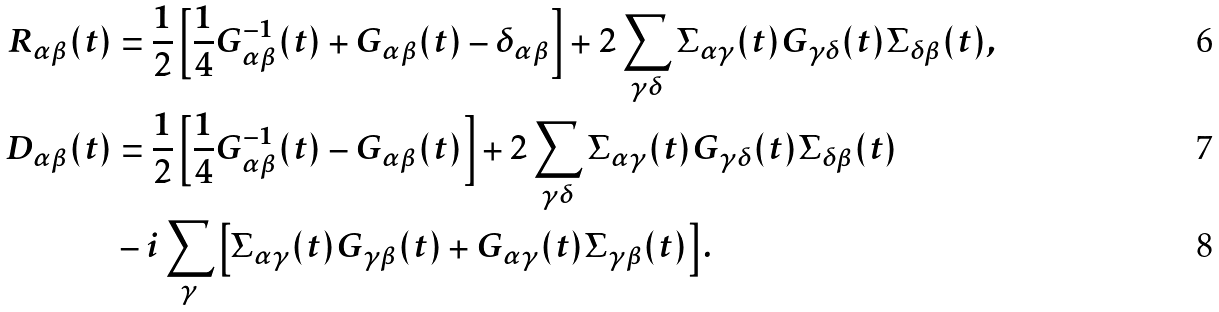Convert formula to latex. <formula><loc_0><loc_0><loc_500><loc_500>R _ { \alpha \beta } ( t ) & = \frac { 1 } { 2 } \left [ \frac { 1 } { 4 } G ^ { - 1 } _ { \alpha \beta } ( t ) + G _ { \alpha \beta } ( t ) - \delta _ { \alpha \beta } \right ] + 2 \sum _ { \gamma \delta } \Sigma _ { \alpha \gamma } ( t ) G _ { \gamma \delta } ( t ) \Sigma _ { \delta \beta } ( t ) , \\ D _ { \alpha \beta } ( t ) & = \frac { 1 } { 2 } \left [ \frac { 1 } { 4 } G ^ { - 1 } _ { \alpha \beta } ( t ) - G _ { \alpha \beta } ( t ) \right ] + 2 \sum _ { \gamma \delta } \Sigma _ { \alpha \gamma } ( t ) G _ { \gamma \delta } ( t ) \Sigma _ { \delta \beta } ( t ) \\ & - i \sum _ { \gamma } \left [ \Sigma _ { \alpha \gamma } ( t ) G _ { \gamma \beta } ( t ) + G _ { \alpha \gamma } ( t ) \Sigma _ { \gamma \beta } ( t ) \right ] .</formula> 